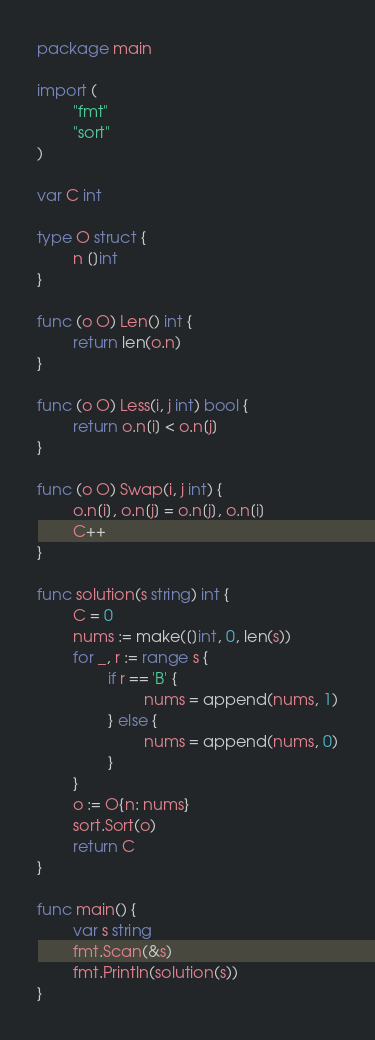Convert code to text. <code><loc_0><loc_0><loc_500><loc_500><_Go_>package main

import (
        "fmt"
        "sort"
)

var C int

type O struct {
        n []int
}

func (o O) Len() int {
        return len(o.n)
}

func (o O) Less(i, j int) bool {
        return o.n[i] < o.n[j]
}

func (o O) Swap(i, j int) {
        o.n[i], o.n[j] = o.n[j], o.n[i]
        C++
}

func solution(s string) int {
        C = 0
        nums := make([]int, 0, len(s))
        for _, r := range s {
                if r == 'B' {
                        nums = append(nums, 1)
                } else {
                        nums = append(nums, 0)
                }
        }
        o := O{n: nums}
        sort.Sort(o)
        return C
}

func main() {
        var s string
        fmt.Scan(&s)
        fmt.Println(solution(s))
}</code> 